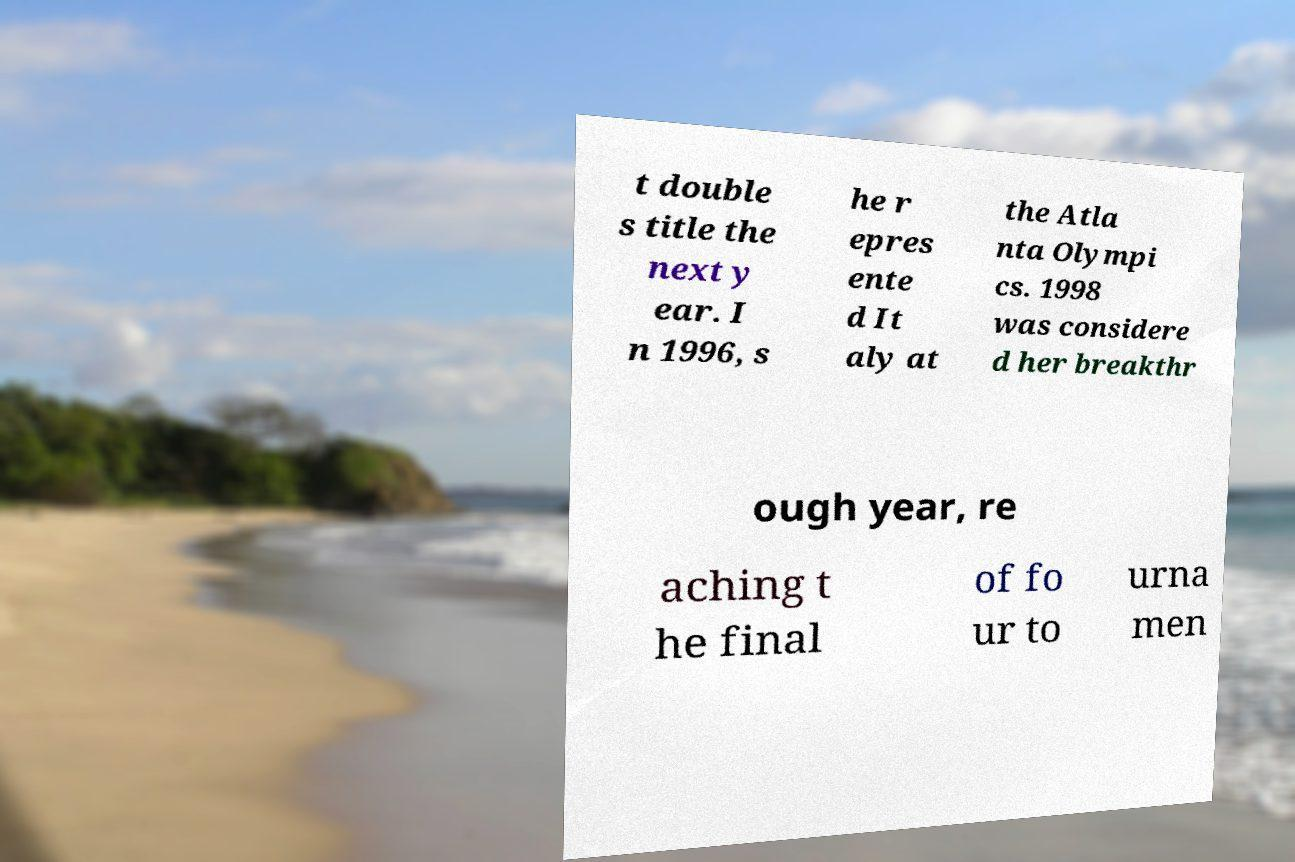Can you accurately transcribe the text from the provided image for me? t double s title the next y ear. I n 1996, s he r epres ente d It aly at the Atla nta Olympi cs. 1998 was considere d her breakthr ough year, re aching t he final of fo ur to urna men 